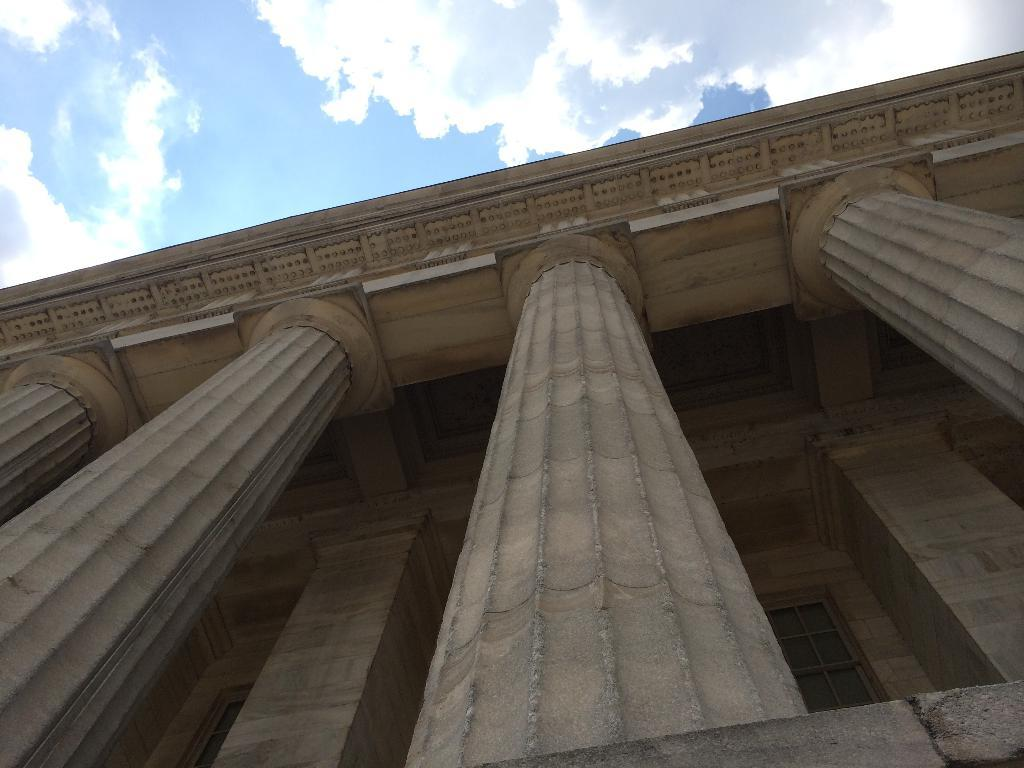What type of structure is present in the image? There is a building in the image. What can be seen in the sky in the image? There are clouds visible in the sky in the image. What type of table is present in the image? There is no table present in the image; it only features a building and clouds in the sky. What type of account is being discussed in the image? There is no account or financial discussion present in the image. 